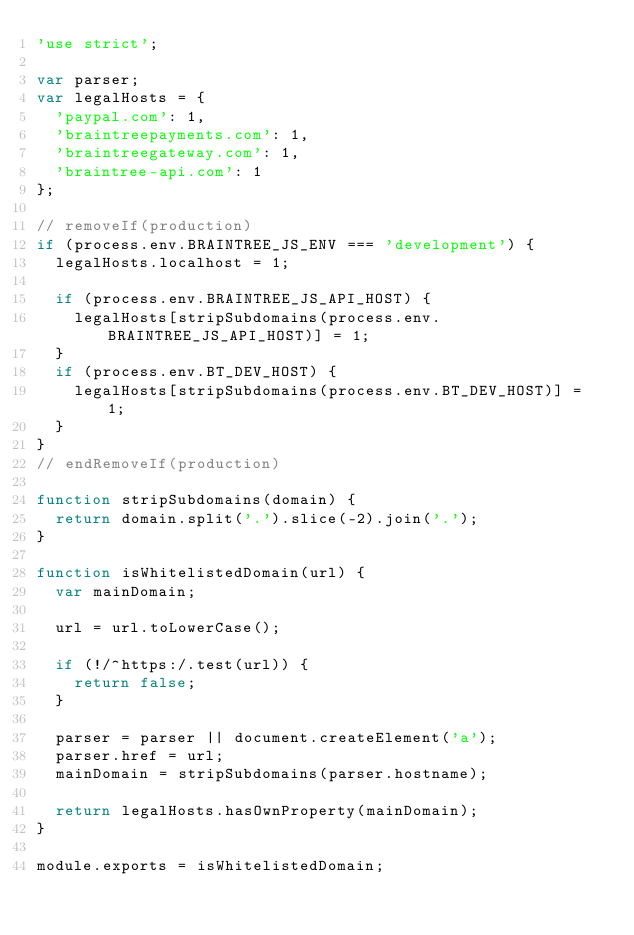Convert code to text. <code><loc_0><loc_0><loc_500><loc_500><_JavaScript_>'use strict';

var parser;
var legalHosts = {
  'paypal.com': 1,
  'braintreepayments.com': 1,
  'braintreegateway.com': 1,
  'braintree-api.com': 1
};

// removeIf(production)
if (process.env.BRAINTREE_JS_ENV === 'development') {
  legalHosts.localhost = 1;

  if (process.env.BRAINTREE_JS_API_HOST) {
    legalHosts[stripSubdomains(process.env.BRAINTREE_JS_API_HOST)] = 1;
  }
  if (process.env.BT_DEV_HOST) {
    legalHosts[stripSubdomains(process.env.BT_DEV_HOST)] = 1;
  }
}
// endRemoveIf(production)

function stripSubdomains(domain) {
  return domain.split('.').slice(-2).join('.');
}

function isWhitelistedDomain(url) {
  var mainDomain;

  url = url.toLowerCase();

  if (!/^https:/.test(url)) {
    return false;
  }

  parser = parser || document.createElement('a');
  parser.href = url;
  mainDomain = stripSubdomains(parser.hostname);

  return legalHosts.hasOwnProperty(mainDomain);
}

module.exports = isWhitelistedDomain;
</code> 